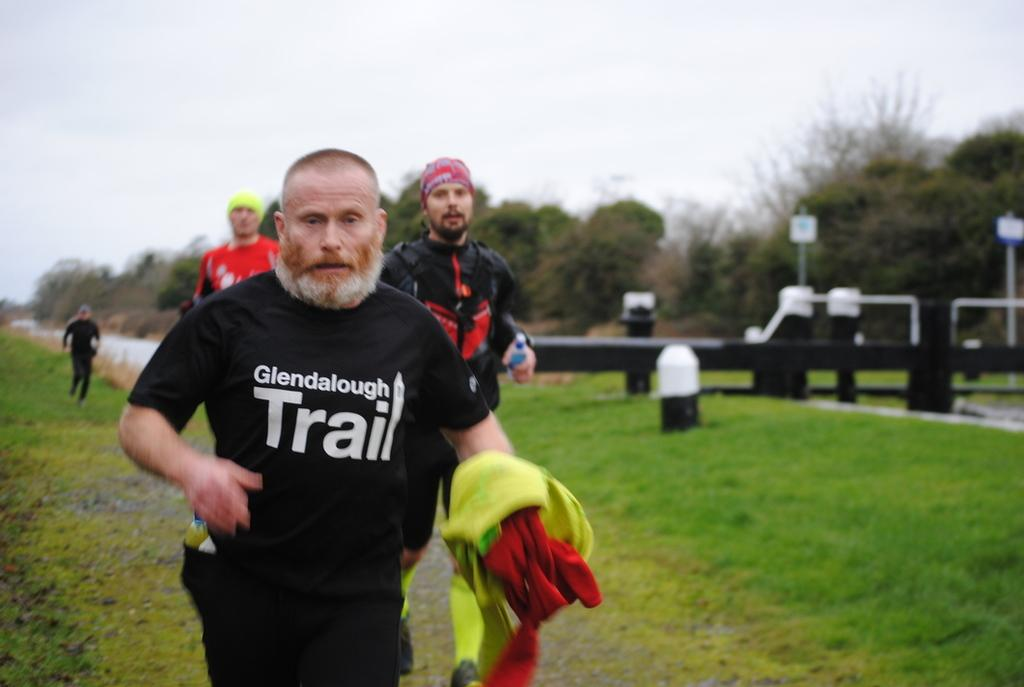What are the people in the image doing? The people in the image are running on the grass. What type of surface are the people running on? The people are running on grass, which is visible in the image. What other natural elements can be seen in the image? There are trees in the image. What type of barrier is present in the image? There is fencing in the image. What type of experience can be felt while standing on the edge of the grass in the image? There is no mention of an edge in the image, and the image does not convey any specific experience. 